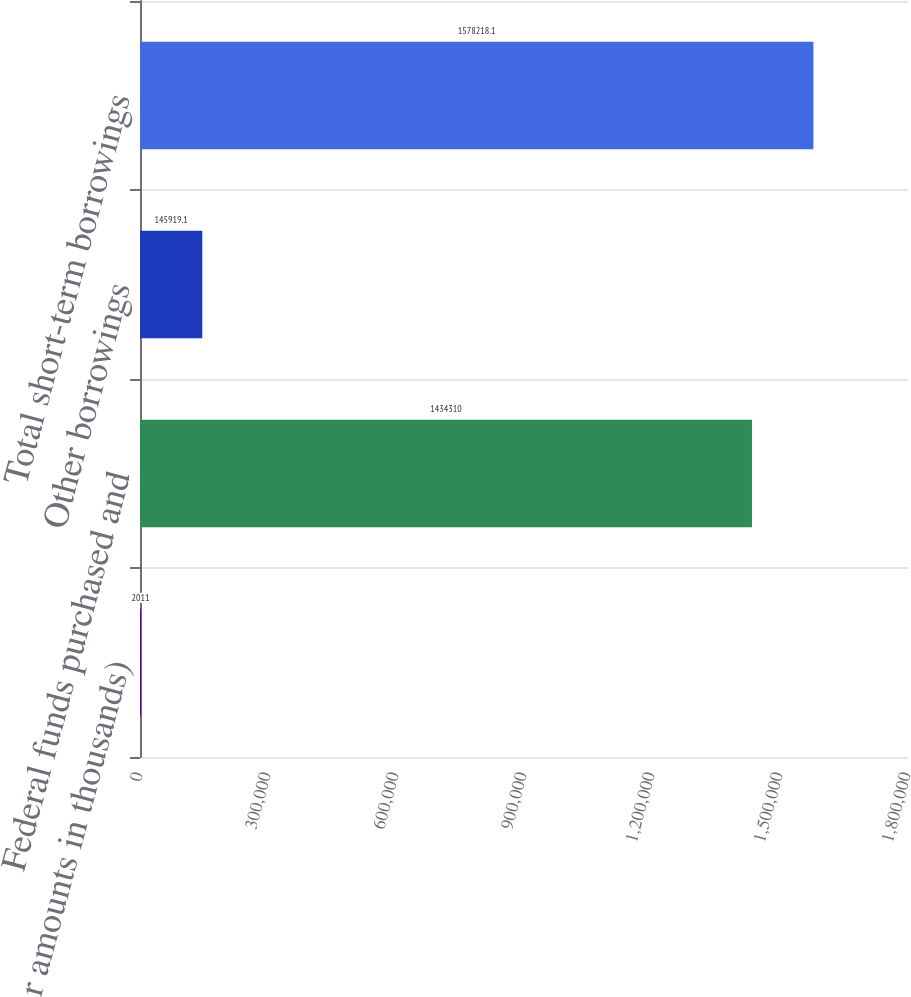Convert chart to OTSL. <chart><loc_0><loc_0><loc_500><loc_500><bar_chart><fcel>(dollar amounts in thousands)<fcel>Federal funds purchased and<fcel>Other borrowings<fcel>Total short-term borrowings<nl><fcel>2011<fcel>1.43431e+06<fcel>145919<fcel>1.57822e+06<nl></chart> 